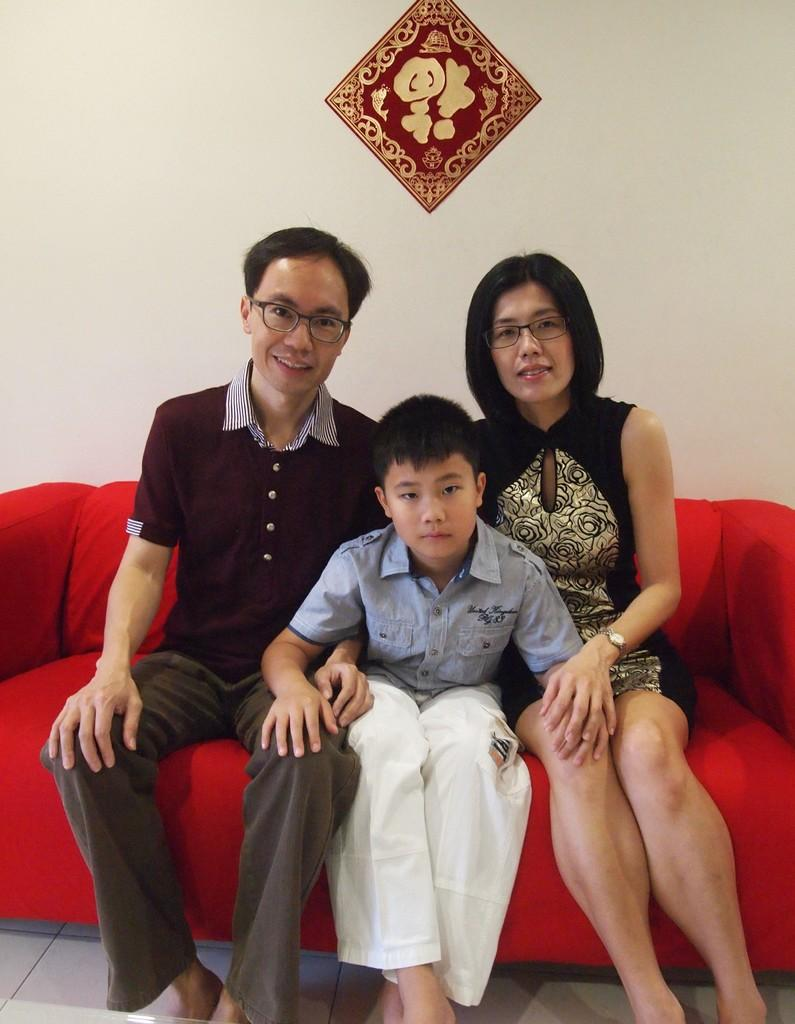Who is present in the image? There is a person in the image, specifically a boy and a woman. What are they sitting on? They are sitting on a red sofa. What can be seen in the background of the image? There is a wall in the background of the image. Is there any decoration or object attached to the wall? Yes, there is a frame attached to the wall. What song is the boy singing in the image? There is no indication in the image that the boy is singing a song, so it cannot be determined from the picture. 